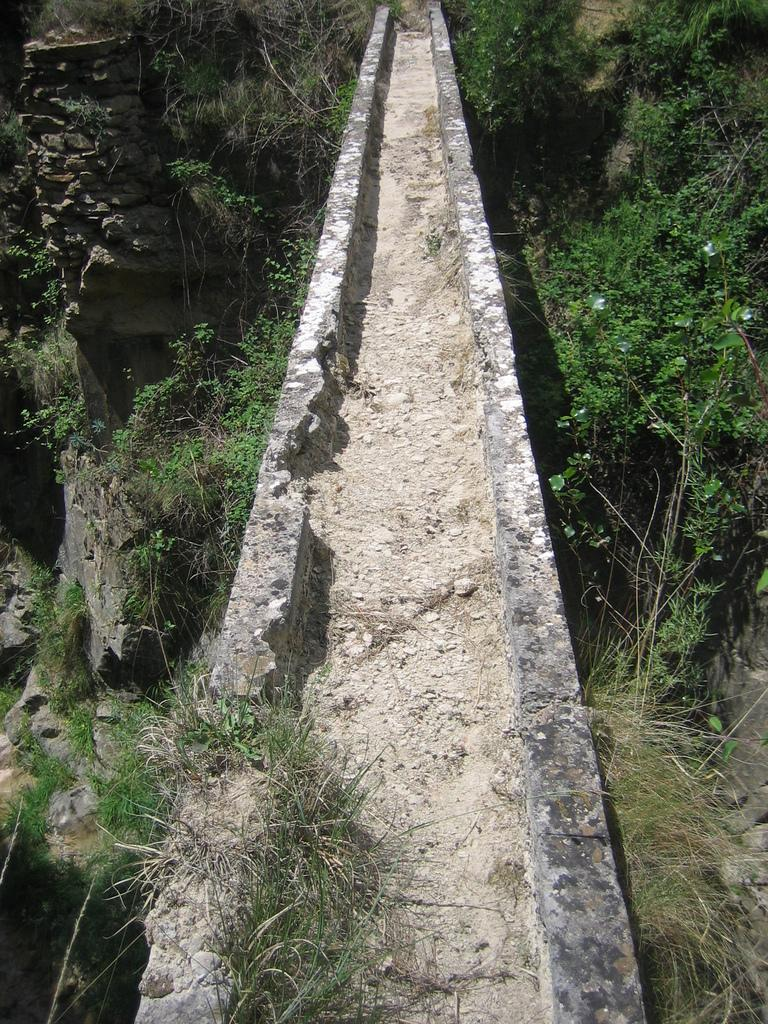What type of structure is present in the image? There is a cement bridge in the image. What can be seen on the right side of the image? There are plants and grass on the right side of the image. What is present on the left side of the image? There are plants, grass, and a rock on the left side of the image. Where is the father in the image? There is no father present in the image; it only features a cement bridge and surrounding vegetation. 